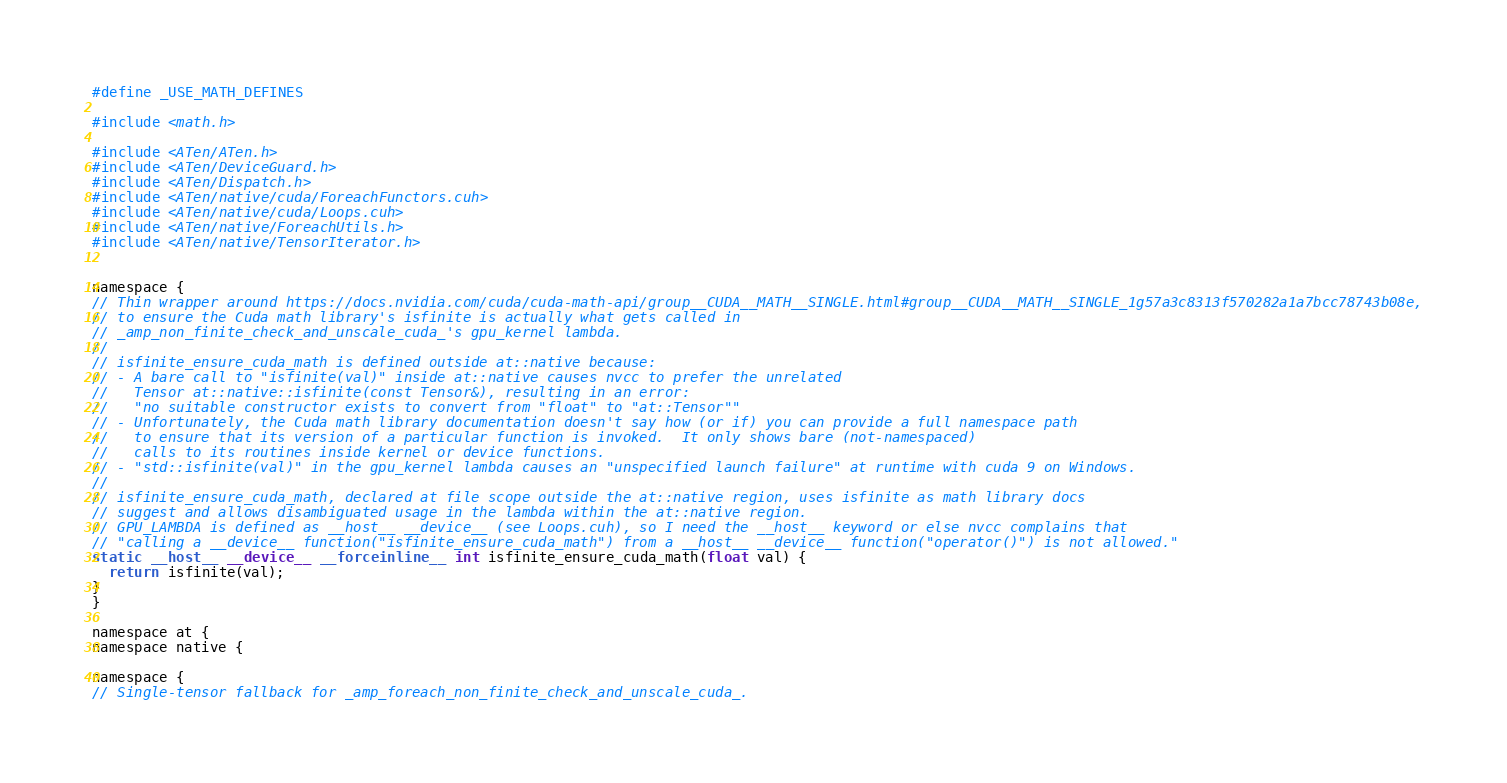Convert code to text. <code><loc_0><loc_0><loc_500><loc_500><_Cuda_>#define _USE_MATH_DEFINES

#include <math.h>

#include <ATen/ATen.h>
#include <ATen/DeviceGuard.h>
#include <ATen/Dispatch.h>
#include <ATen/native/cuda/ForeachFunctors.cuh>
#include <ATen/native/cuda/Loops.cuh>
#include <ATen/native/ForeachUtils.h>
#include <ATen/native/TensorIterator.h>


namespace {
// Thin wrapper around https://docs.nvidia.com/cuda/cuda-math-api/group__CUDA__MATH__SINGLE.html#group__CUDA__MATH__SINGLE_1g57a3c8313f570282a1a7bcc78743b08e,
// to ensure the Cuda math library's isfinite is actually what gets called in
// _amp_non_finite_check_and_unscale_cuda_'s gpu_kernel lambda.
//
// isfinite_ensure_cuda_math is defined outside at::native because:
// - A bare call to "isfinite(val)" inside at::native causes nvcc to prefer the unrelated
//   Tensor at::native::isfinite(const Tensor&), resulting in an error:
//   "no suitable constructor exists to convert from "float" to "at::Tensor""
// - Unfortunately, the Cuda math library documentation doesn't say how (or if) you can provide a full namespace path
//   to ensure that its version of a particular function is invoked.  It only shows bare (not-namespaced)
//   calls to its routines inside kernel or device functions.
// - "std::isfinite(val)" in the gpu_kernel lambda causes an "unspecified launch failure" at runtime with cuda 9 on Windows.
//
// isfinite_ensure_cuda_math, declared at file scope outside the at::native region, uses isfinite as math library docs
// suggest and allows disambiguated usage in the lambda within the at::native region.
// GPU_LAMBDA is defined as __host__ __device__ (see Loops.cuh), so I need the __host__ keyword or else nvcc complains that
// "calling a __device__ function("isfinite_ensure_cuda_math") from a __host__ __device__ function("operator()") is not allowed."
static __host__ __device__ __forceinline__ int isfinite_ensure_cuda_math(float val) {
  return isfinite(val);
}
}

namespace at {
namespace native {

namespace {
// Single-tensor fallback for _amp_foreach_non_finite_check_and_unscale_cuda_.</code> 